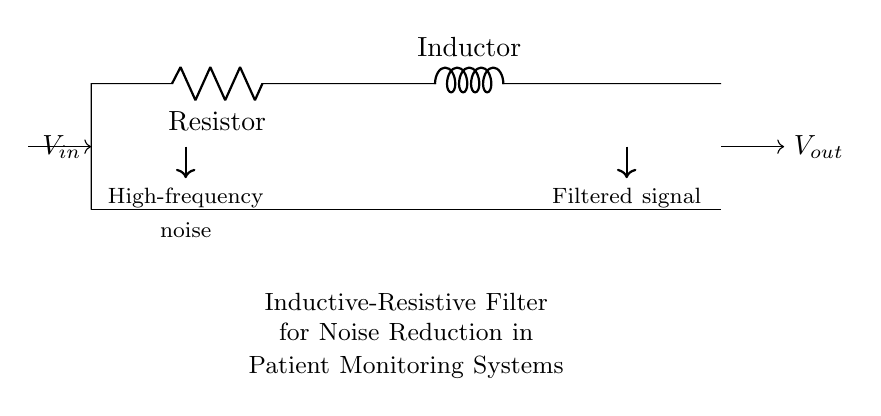What is the primary purpose of this circuit? The circuit is designed as an inductive-resistive filter primarily for noise reduction in patient monitoring systems, as indicated by the text label in the diagram.
Answer: Noise reduction What components are present in the circuit? The circuit contains two components: a resistor (R) and an inductor (L), as labeled in the diagram.
Answer: Resistor and inductor What is the expected output after filtering? The output of the circuit is expected to be a filtered signal with reduced high-frequency noise, as shown by the labels on the arrows indicating the flow of input and output.
Answer: Filtered signal How does the resistor impact the circuit's behavior? The resistor introduces resistance which dissipates energy as heat and helps to set the time constant of the circuit, affecting how quickly it responds to changes in input.
Answer: Introduces resistance What is the function of the inductor in this circuit? The inductor impedes changes in current and helps to block high-frequency noise while allowing lower-frequency signals to pass through, which is beneficial in a filtering application.
Answer: Blocks high-frequency noise What type of filter is this circuit classified as? The circuit is classified as a low-pass filter, as it allows low-frequency signals to pass while attenuating high-frequency components, suitable for reducing noise in patient monitoring systems.
Answer: Low-pass filter 